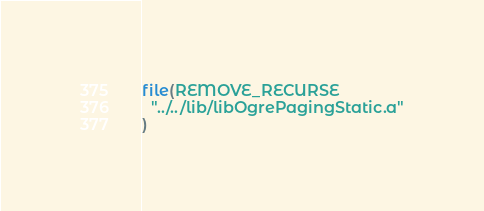Convert code to text. <code><loc_0><loc_0><loc_500><loc_500><_CMake_>file(REMOVE_RECURSE
  "../../lib/libOgrePagingStatic.a"
)
</code> 